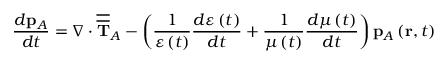<formula> <loc_0><loc_0><loc_500><loc_500>\frac { d p _ { A } } { d t } = \nabla \cdot \overline { { \overline { T } } } _ { A } - \left ( \frac { 1 } { \varepsilon \left ( t \right ) } \frac { d \varepsilon \left ( t \right ) } { d t } + \frac { 1 } { \mu \left ( t \right ) } \frac { d \mu \left ( t \right ) } { d t } \right ) p _ { A } \left ( r , t \right )</formula> 